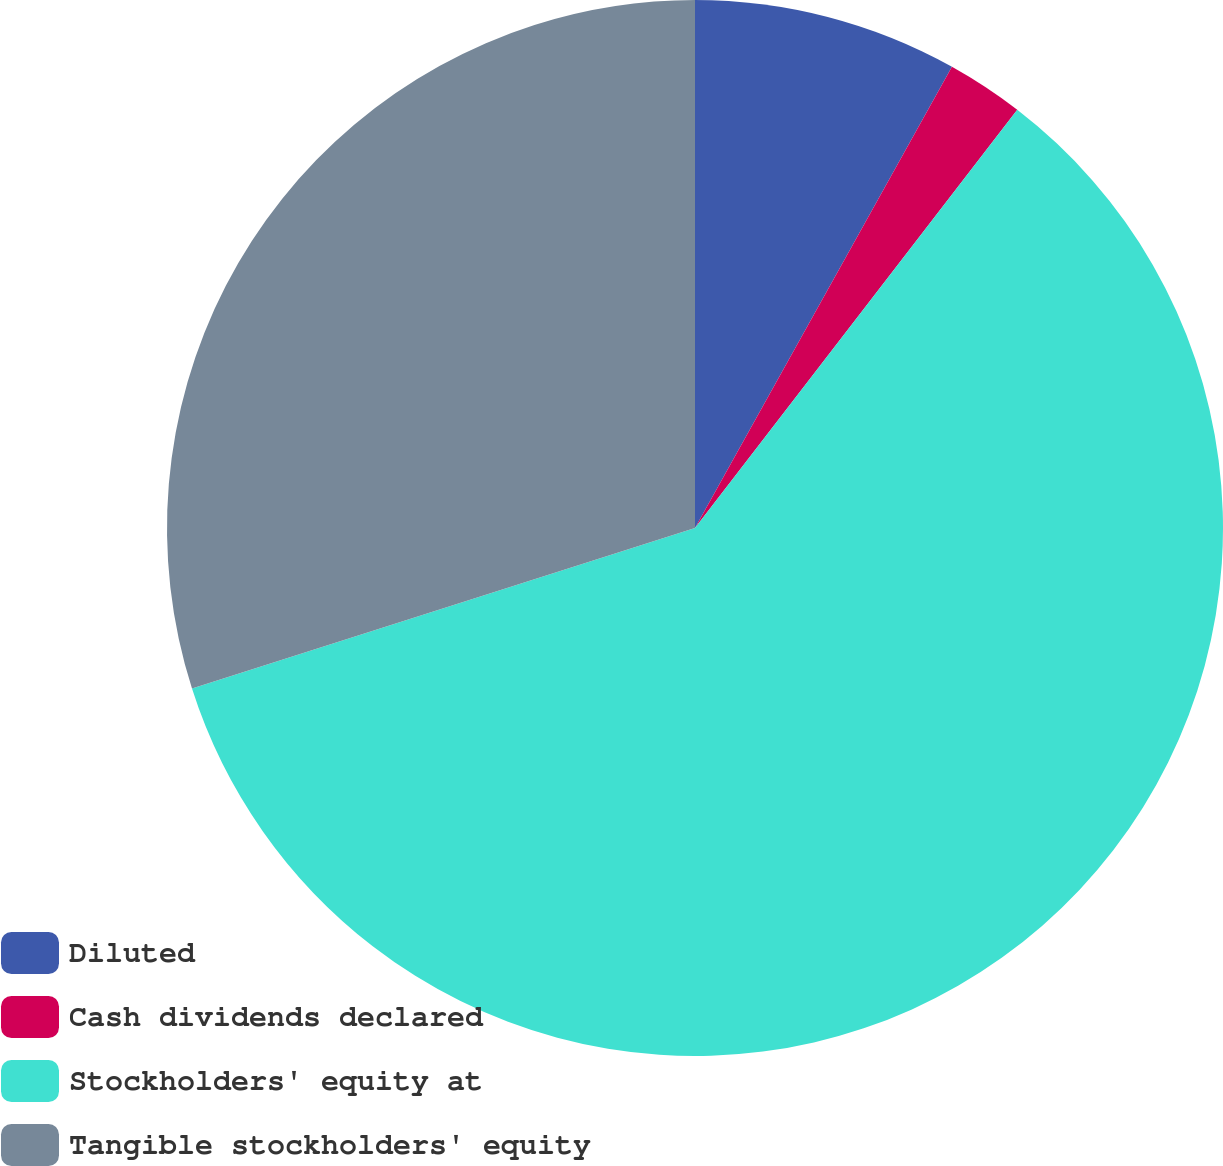Convert chart to OTSL. <chart><loc_0><loc_0><loc_500><loc_500><pie_chart><fcel>Diluted<fcel>Cash dividends declared<fcel>Stockholders' equity at<fcel>Tangible stockholders' equity<nl><fcel>8.09%<fcel>2.36%<fcel>59.64%<fcel>29.92%<nl></chart> 